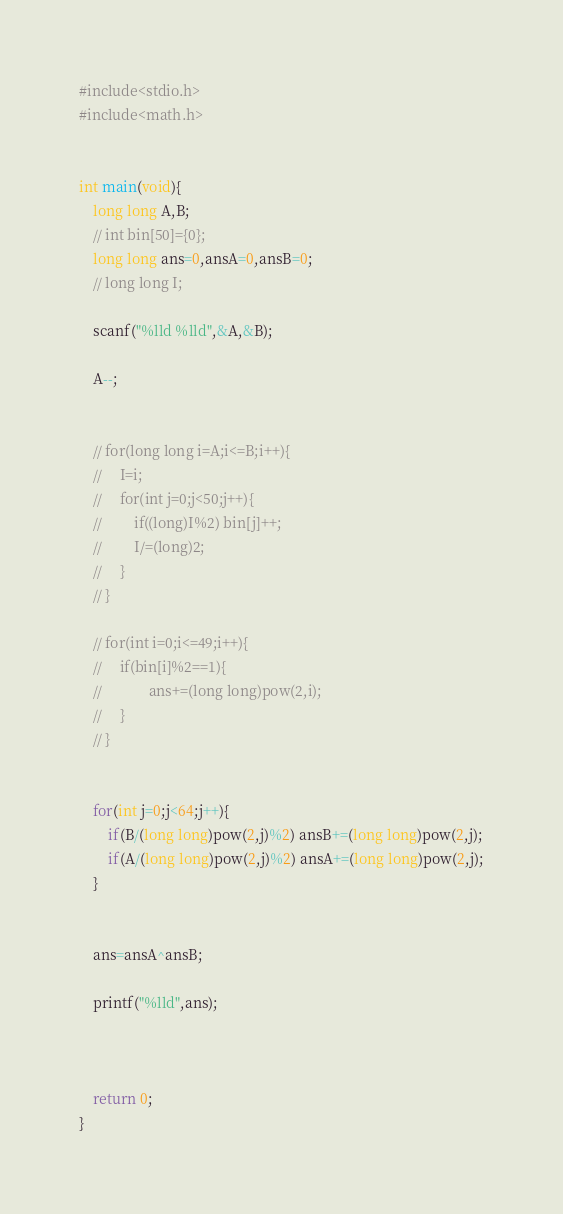Convert code to text. <code><loc_0><loc_0><loc_500><loc_500><_C_>#include<stdio.h>
#include<math.h>


int main(void){
    long long A,B;
    // int bin[50]={0};
    long long ans=0,ansA=0,ansB=0;
    // long long I;

    scanf("%lld %lld",&A,&B);

    A--;


    // for(long long i=A;i<=B;i++){
    //     I=i;
    //     for(int j=0;j<50;j++){
    //         if((long)I%2) bin[j]++;
    //         I/=(long)2;
    //     }
    // }

    // for(int i=0;i<=49;i++){
    //     if(bin[i]%2==1){
    //             ans+=(long long)pow(2,i);
    //     }
    // }


    for(int j=0;j<64;j++){
        if(B/(long long)pow(2,j)%2) ansB+=(long long)pow(2,j);
        if(A/(long long)pow(2,j)%2) ansA+=(long long)pow(2,j);
    }


    ans=ansA^ansB;
    
    printf("%lld",ans);
    
    

    return 0;
}</code> 